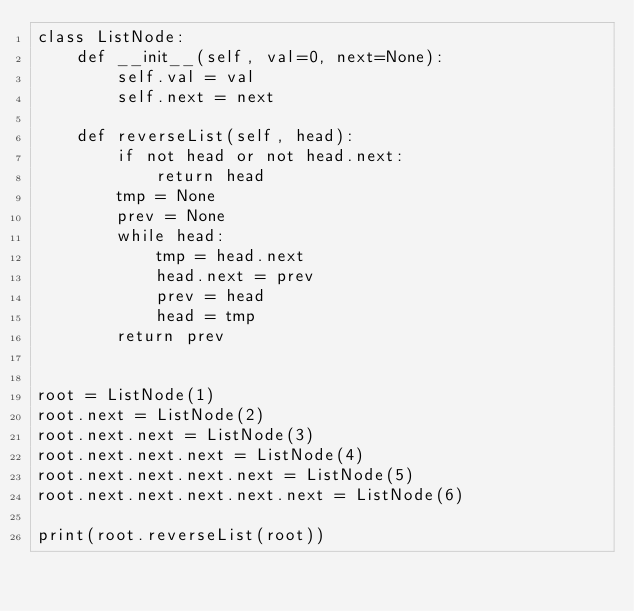Convert code to text. <code><loc_0><loc_0><loc_500><loc_500><_Python_>class ListNode:
    def __init__(self, val=0, next=None):
        self.val = val
        self.next = next

    def reverseList(self, head):
        if not head or not head.next:
            return head
        tmp = None
        prev = None
        while head:
            tmp = head.next
            head.next = prev
            prev = head
            head = tmp
        return prev


root = ListNode(1)
root.next = ListNode(2)
root.next.next = ListNode(3)
root.next.next.next = ListNode(4)
root.next.next.next.next = ListNode(5)
root.next.next.next.next.next = ListNode(6)

print(root.reverseList(root))
</code> 